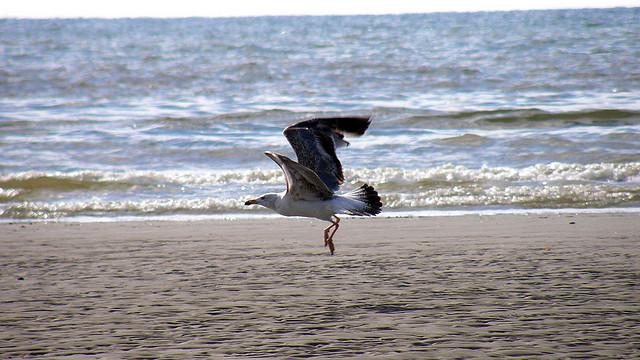Is the bird in the air?
Concise answer only. Yes. Is this bird found near bodies of water?
Quick response, please. Yes. Is the bird eating?
Quick response, please. No. 